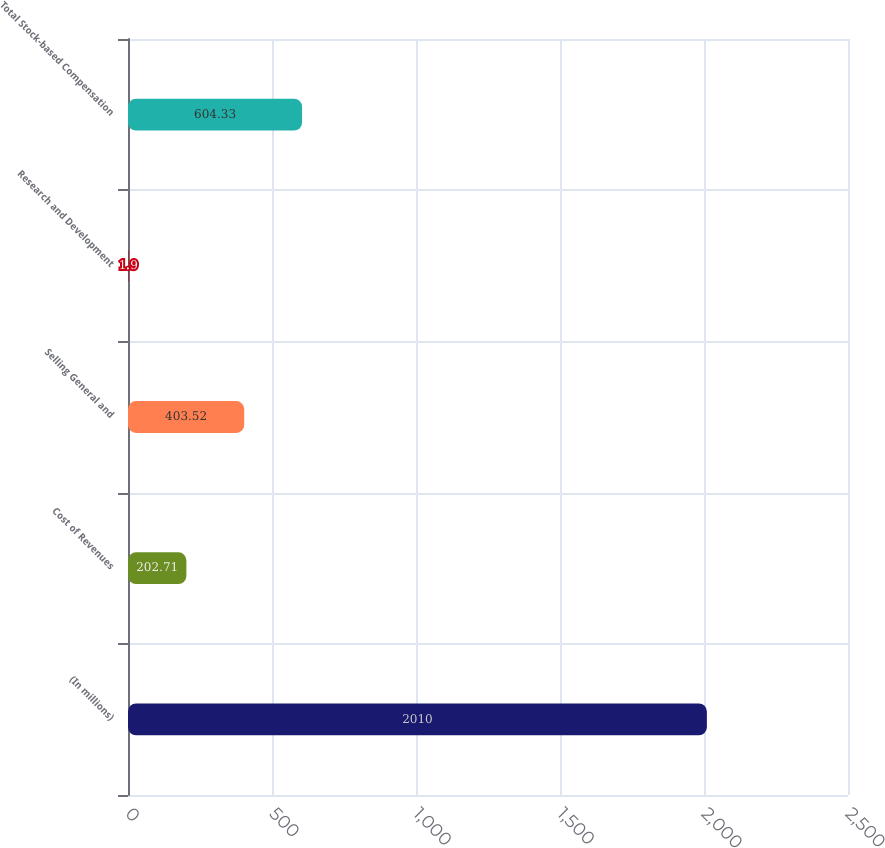Convert chart to OTSL. <chart><loc_0><loc_0><loc_500><loc_500><bar_chart><fcel>(In millions)<fcel>Cost of Revenues<fcel>Selling General and<fcel>Research and Development<fcel>Total Stock-based Compensation<nl><fcel>2010<fcel>202.71<fcel>403.52<fcel>1.9<fcel>604.33<nl></chart> 